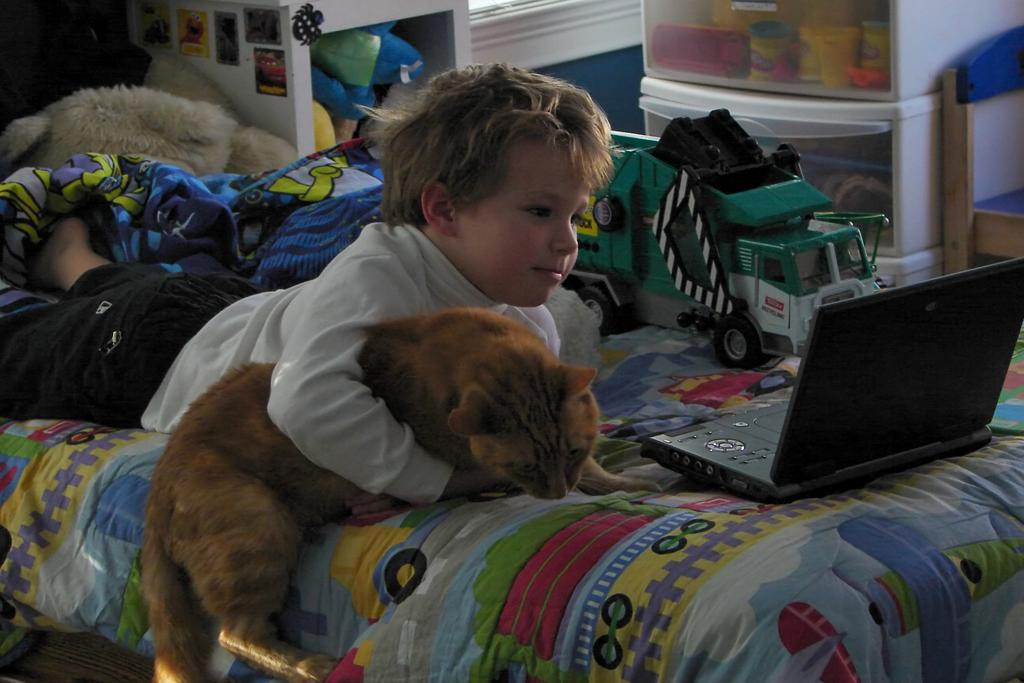What is the main subject in the center of the image? There is a boy in the center of the image. What is the boy holding in the image? The boy is holding a cat. Where is the cat lying in the image? The cat is lying on a bed. What can be found on the bed besides the cat? There is a table, a toy, a bed sheet, and other unspecified objects on the bed. What can be seen in the background of the image? There is a table and a chair in the background, along with other unspecified objects. What type of thunder can be heard in the image? There is no mention of thunder in the image, so it cannot be heard or seen. 